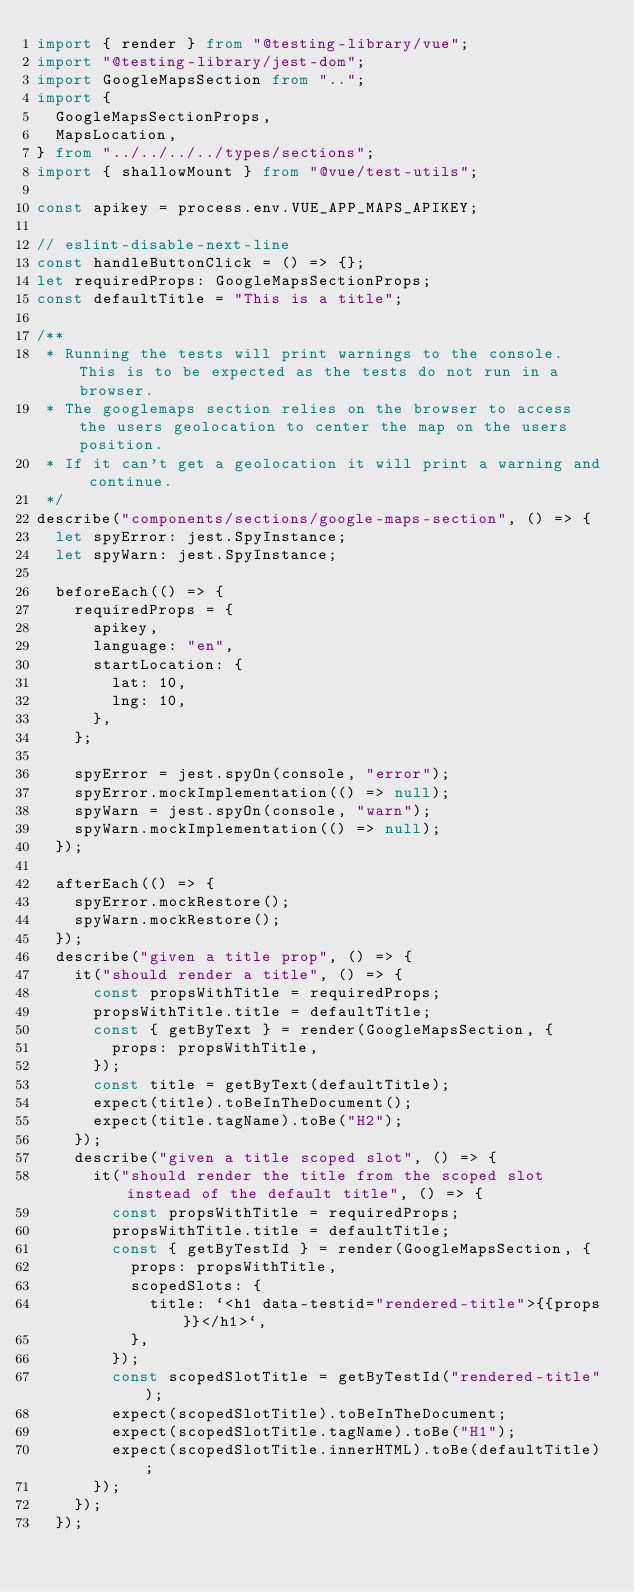<code> <loc_0><loc_0><loc_500><loc_500><_TypeScript_>import { render } from "@testing-library/vue";
import "@testing-library/jest-dom";
import GoogleMapsSection from "..";
import {
  GoogleMapsSectionProps,
  MapsLocation,
} from "../../../../types/sections";
import { shallowMount } from "@vue/test-utils";

const apikey = process.env.VUE_APP_MAPS_APIKEY;

// eslint-disable-next-line
const handleButtonClick = () => {};
let requiredProps: GoogleMapsSectionProps;
const defaultTitle = "This is a title";

/**
 * Running the tests will print warnings to the console. This is to be expected as the tests do not run in a browser.
 * The googlemaps section relies on the browser to access the users geolocation to center the map on the users position.
 * If it can't get a geolocation it will print a warning and continue.
 */
describe("components/sections/google-maps-section", () => {
  let spyError: jest.SpyInstance;
  let spyWarn: jest.SpyInstance;

  beforeEach(() => {
    requiredProps = {
      apikey,
      language: "en",
      startLocation: {
        lat: 10,
        lng: 10,
      },
    };

    spyError = jest.spyOn(console, "error");
    spyError.mockImplementation(() => null);
    spyWarn = jest.spyOn(console, "warn");
    spyWarn.mockImplementation(() => null);
  });

  afterEach(() => {
    spyError.mockRestore();
    spyWarn.mockRestore();
  });
  describe("given a title prop", () => {
    it("should render a title", () => {
      const propsWithTitle = requiredProps;
      propsWithTitle.title = defaultTitle;
      const { getByText } = render(GoogleMapsSection, {
        props: propsWithTitle,
      });
      const title = getByText(defaultTitle);
      expect(title).toBeInTheDocument();
      expect(title.tagName).toBe("H2");
    });
    describe("given a title scoped slot", () => {
      it("should render the title from the scoped slot instead of the default title", () => {
        const propsWithTitle = requiredProps;
        propsWithTitle.title = defaultTitle;
        const { getByTestId } = render(GoogleMapsSection, {
          props: propsWithTitle,
          scopedSlots: {
            title: `<h1 data-testid="rendered-title">{{props}}</h1>`,
          },
        });
        const scopedSlotTitle = getByTestId("rendered-title");
        expect(scopedSlotTitle).toBeInTheDocument;
        expect(scopedSlotTitle.tagName).toBe("H1");
        expect(scopedSlotTitle.innerHTML).toBe(defaultTitle);
      });
    });
  });</code> 